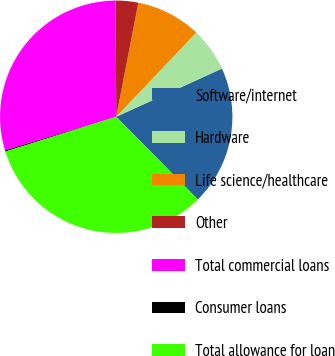Convert chart. <chart><loc_0><loc_0><loc_500><loc_500><pie_chart><fcel>Software/internet<fcel>Hardware<fcel>Life science/healthcare<fcel>Other<fcel>Total commercial loans<fcel>Consumer loans<fcel>Total allowance for loan<nl><fcel>19.41%<fcel>6.09%<fcel>9.05%<fcel>3.13%<fcel>29.59%<fcel>0.17%<fcel>32.55%<nl></chart> 